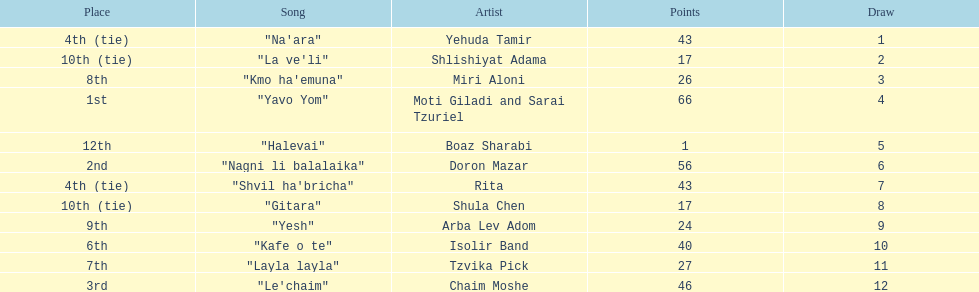How many points does the artist rita have? 43. 